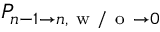Convert formula to latex. <formula><loc_0><loc_0><loc_500><loc_500>P _ { n - 1 \to n , w / o \to 0 }</formula> 